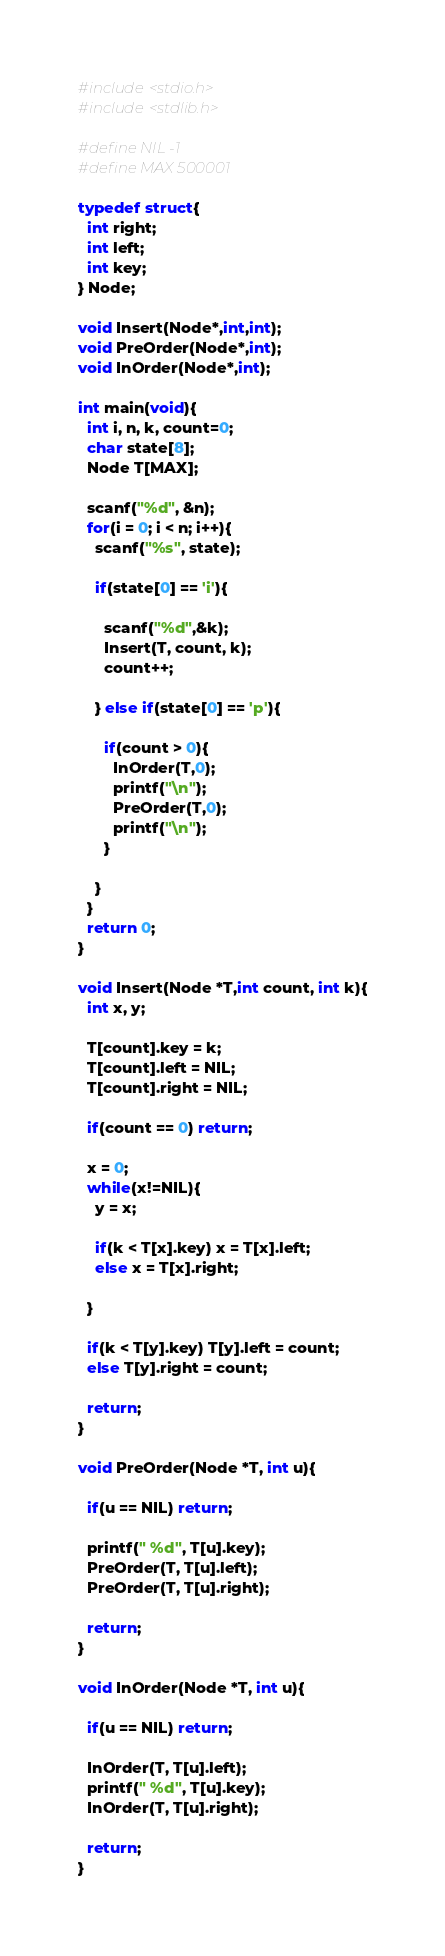Convert code to text. <code><loc_0><loc_0><loc_500><loc_500><_C_>#include<stdio.h>
#include<stdlib.h>
 
#define NIL -1
#define MAX 500001
 
typedef struct{
  int right;
  int left;
  int key;
} Node;
 
void Insert(Node*,int,int);
void PreOrder(Node*,int);
void InOrder(Node*,int);
 
int main(void){
  int i, n, k, count=0;
  char state[8];
  Node T[MAX];
 
  scanf("%d", &n);
  for(i = 0; i < n; i++){
    scanf("%s", state);
 
    if(state[0] == 'i'){
 
      scanf("%d",&k);
      Insert(T, count, k);
      count++;
 
    } else if(state[0] == 'p'){
 
      if(count > 0){
        InOrder(T,0);
        printf("\n");
        PreOrder(T,0);
        printf("\n");
      }
 
    }
  }
  return 0;
}
 
void Insert(Node *T,int count, int k){
  int x, y;
 
  T[count].key = k;
  T[count].left = NIL;
  T[count].right = NIL;
 
  if(count == 0) return;
 
  x = 0;
  while(x!=NIL){
    y = x;
 
    if(k < T[x].key) x = T[x].left;
    else x = T[x].right;
 
  }
 
  if(k < T[y].key) T[y].left = count;
  else T[y].right = count;
 
  return;
}
 
void PreOrder(Node *T, int u){
 
  if(u == NIL) return;
 
  printf(" %d", T[u].key);
  PreOrder(T, T[u].left);
  PreOrder(T, T[u].right);
 
  return;
}
 
void InOrder(Node *T, int u){
 
  if(u == NIL) return;
 
  InOrder(T, T[u].left);
  printf(" %d", T[u].key);
  InOrder(T, T[u].right);
 
  return;
}</code> 